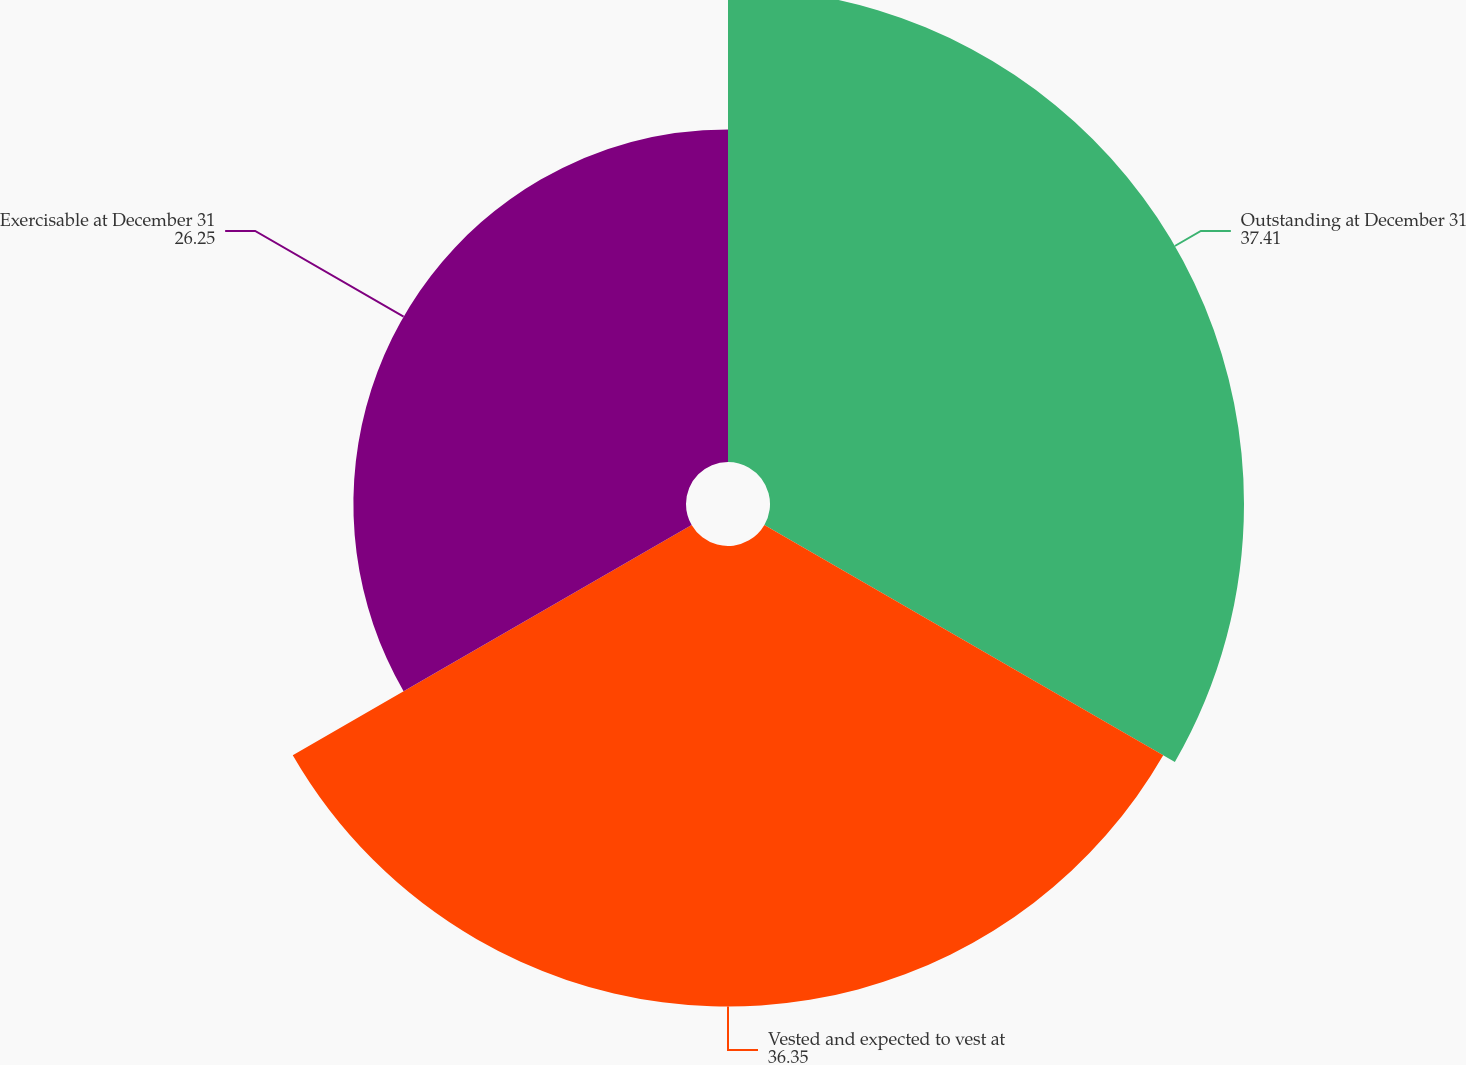Convert chart to OTSL. <chart><loc_0><loc_0><loc_500><loc_500><pie_chart><fcel>Outstanding at December 31<fcel>Vested and expected to vest at<fcel>Exercisable at December 31<nl><fcel>37.41%<fcel>36.35%<fcel>26.25%<nl></chart> 